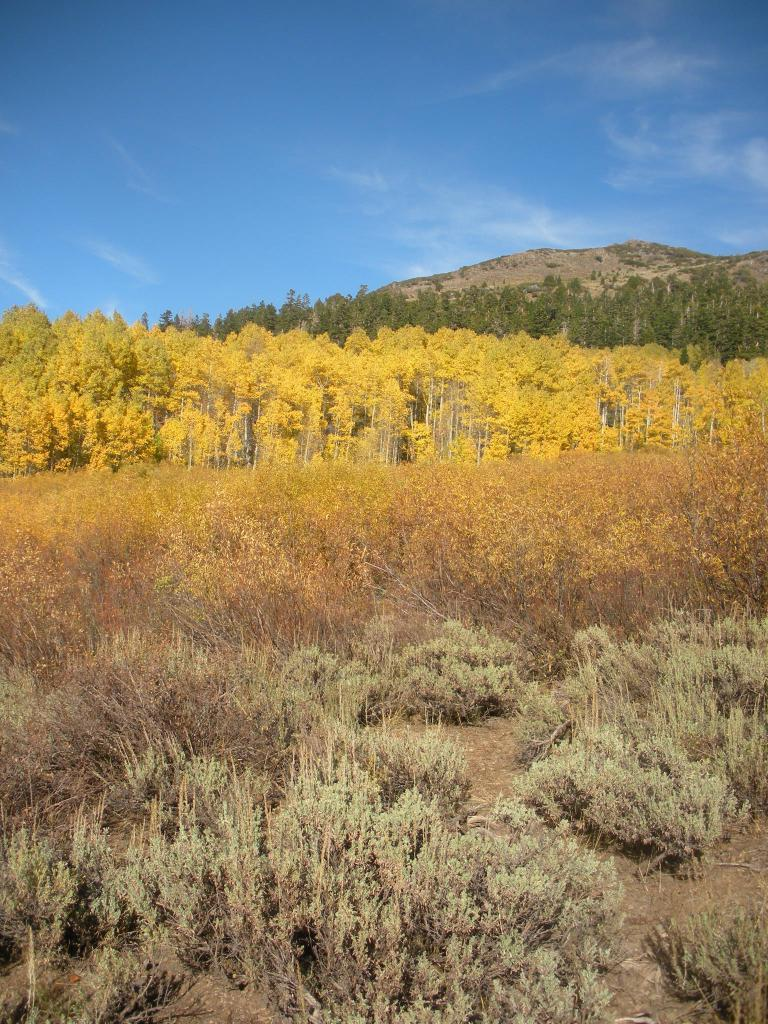What types of vegetation can be seen in the foreground of the picture? There are plants and shrubs in the foreground of the picture. What is located in the center of the picture? There are trees in the center of the picture. What geographical feature is visible in the background of the picture? There is a hill in the background of the picture. What is the weather like in the image? The sky is sunny in the image. What type of wire can be seen hanging from the trees in the image? There is no wire visible in the image; it only features plants, shrubs, trees, and a hill. What story is being told by the wren perched on the hill in the image? There is no wren present in the image, and therefore no story can be told by it. 